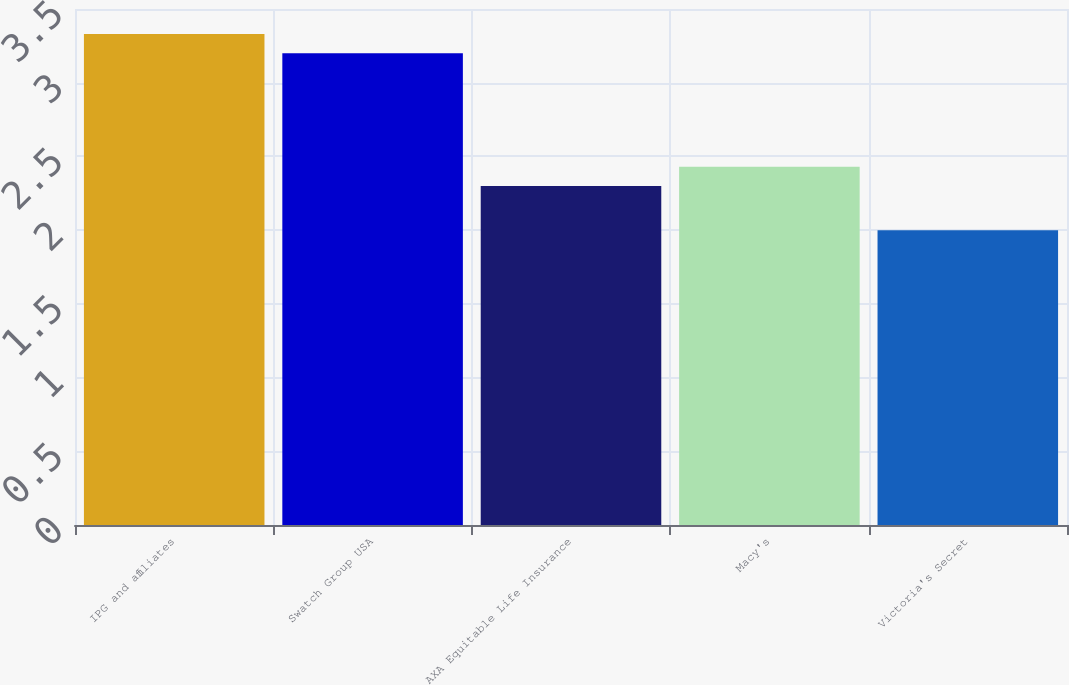<chart> <loc_0><loc_0><loc_500><loc_500><bar_chart><fcel>IPG and affiliates<fcel>Swatch Group USA<fcel>AXA Equitable Life Insurance<fcel>Macy's<fcel>Victoria's Secret<nl><fcel>3.33<fcel>3.2<fcel>2.3<fcel>2.43<fcel>2<nl></chart> 